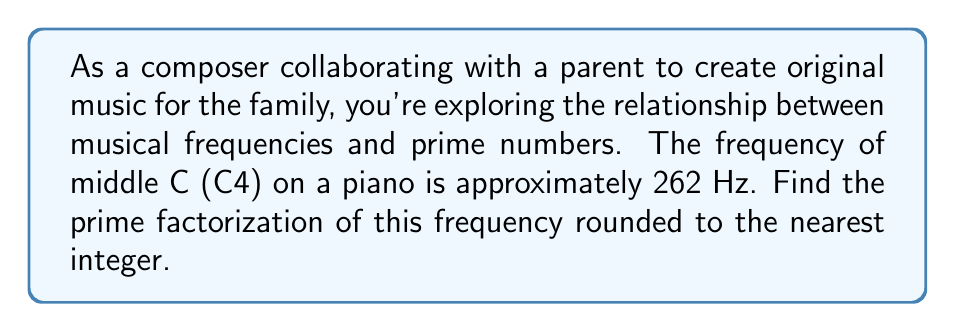Can you answer this question? To solve this problem, we'll follow these steps:

1) First, we round 262 Hz to the nearest integer: 262 Hz

2) Now, we need to find the prime factorization of 262. We'll do this by dividing by prime numbers, starting with the smallest:

   $262 = 2 \times 131$

3) 131 is itself a prime number, so we stop here.

Therefore, the prime factorization of 262 is:

$262 = 2 \times 131$

This factorization is interesting from a musical perspective. The factor of 2 represents an octave in music (doubling a frequency raises the pitch by one octave). The prime factor 131 represents a unique frequency ratio that can't be further broken down into simpler musical intervals.

As a composer, you might find it intriguing to explore how these prime factors relate to the harmonic series and overtones of this fundamental frequency, potentially inspiring unique compositional ideas for your family-oriented music.
Answer: $262 = 2 \times 131$ 